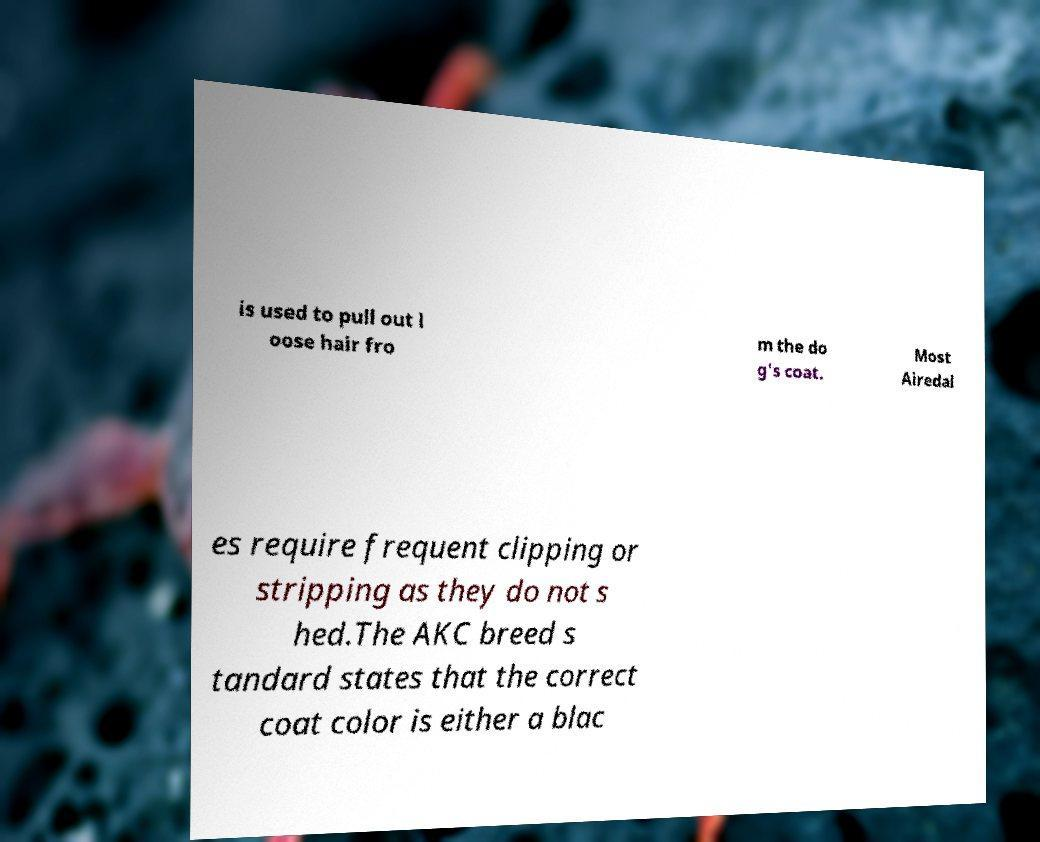Could you extract and type out the text from this image? is used to pull out l oose hair fro m the do g's coat. Most Airedal es require frequent clipping or stripping as they do not s hed.The AKC breed s tandard states that the correct coat color is either a blac 